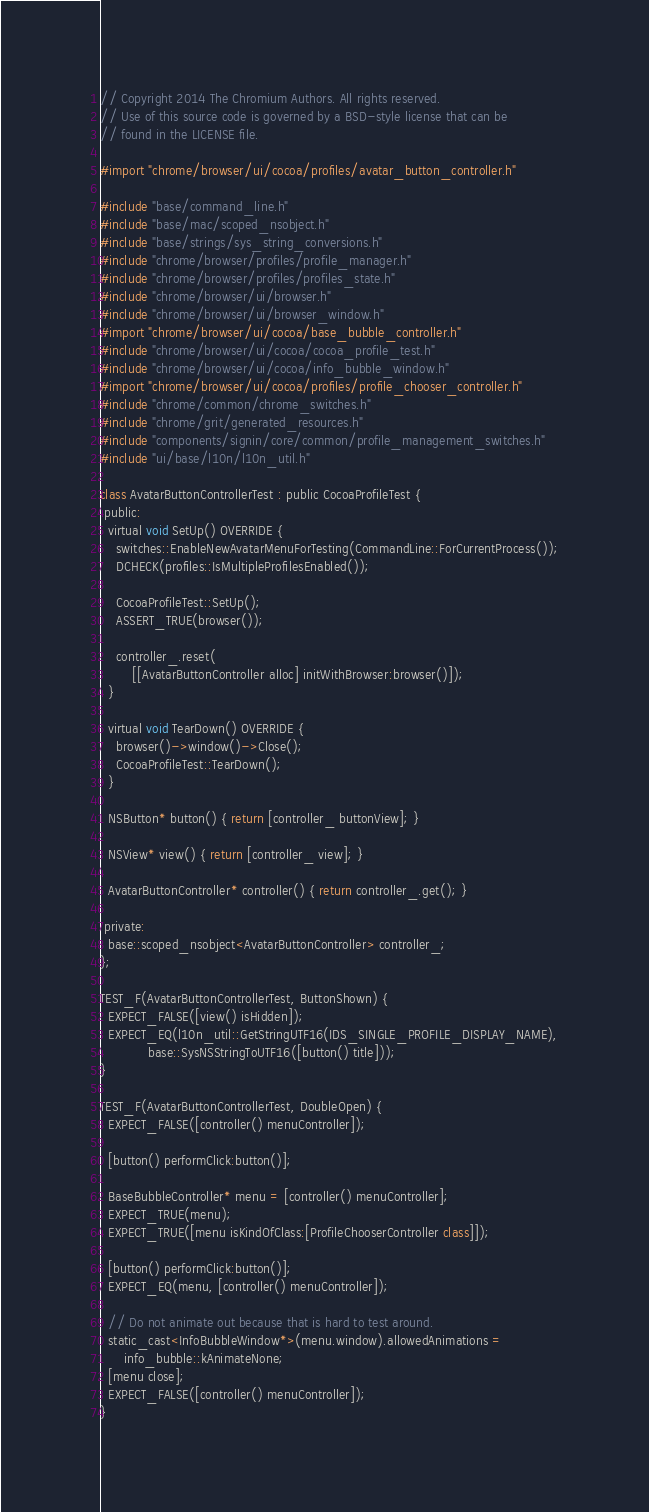Convert code to text. <code><loc_0><loc_0><loc_500><loc_500><_ObjectiveC_>// Copyright 2014 The Chromium Authors. All rights reserved.
// Use of this source code is governed by a BSD-style license that can be
// found in the LICENSE file.

#import "chrome/browser/ui/cocoa/profiles/avatar_button_controller.h"

#include "base/command_line.h"
#include "base/mac/scoped_nsobject.h"
#include "base/strings/sys_string_conversions.h"
#include "chrome/browser/profiles/profile_manager.h"
#include "chrome/browser/profiles/profiles_state.h"
#include "chrome/browser/ui/browser.h"
#include "chrome/browser/ui/browser_window.h"
#import "chrome/browser/ui/cocoa/base_bubble_controller.h"
#include "chrome/browser/ui/cocoa/cocoa_profile_test.h"
#include "chrome/browser/ui/cocoa/info_bubble_window.h"
#import "chrome/browser/ui/cocoa/profiles/profile_chooser_controller.h"
#include "chrome/common/chrome_switches.h"
#include "chrome/grit/generated_resources.h"
#include "components/signin/core/common/profile_management_switches.h"
#include "ui/base/l10n/l10n_util.h"

class AvatarButtonControllerTest : public CocoaProfileTest {
 public:
  virtual void SetUp() OVERRIDE {
    switches::EnableNewAvatarMenuForTesting(CommandLine::ForCurrentProcess());
    DCHECK(profiles::IsMultipleProfilesEnabled());

    CocoaProfileTest::SetUp();
    ASSERT_TRUE(browser());

    controller_.reset(
        [[AvatarButtonController alloc] initWithBrowser:browser()]);
  }

  virtual void TearDown() OVERRIDE {
    browser()->window()->Close();
    CocoaProfileTest::TearDown();
  }

  NSButton* button() { return [controller_ buttonView]; }

  NSView* view() { return [controller_ view]; }

  AvatarButtonController* controller() { return controller_.get(); }

 private:
  base::scoped_nsobject<AvatarButtonController> controller_;
};

TEST_F(AvatarButtonControllerTest, ButtonShown) {
  EXPECT_FALSE([view() isHidden]);
  EXPECT_EQ(l10n_util::GetStringUTF16(IDS_SINGLE_PROFILE_DISPLAY_NAME),
            base::SysNSStringToUTF16([button() title]));
}

TEST_F(AvatarButtonControllerTest, DoubleOpen) {
  EXPECT_FALSE([controller() menuController]);

  [button() performClick:button()];

  BaseBubbleController* menu = [controller() menuController];
  EXPECT_TRUE(menu);
  EXPECT_TRUE([menu isKindOfClass:[ProfileChooserController class]]);

  [button() performClick:button()];
  EXPECT_EQ(menu, [controller() menuController]);

  // Do not animate out because that is hard to test around.
  static_cast<InfoBubbleWindow*>(menu.window).allowedAnimations =
      info_bubble::kAnimateNone;
  [menu close];
  EXPECT_FALSE([controller() menuController]);
}
</code> 